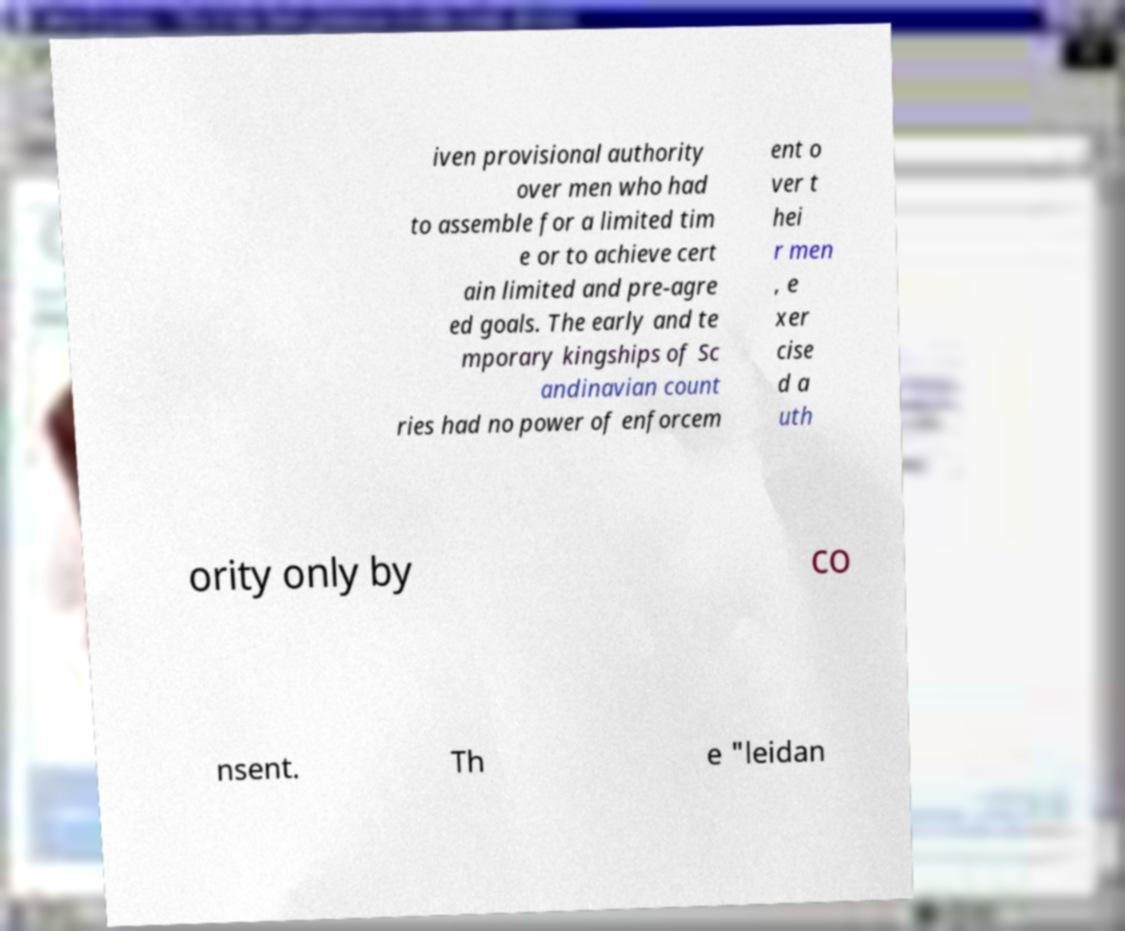Could you extract and type out the text from this image? iven provisional authority over men who had to assemble for a limited tim e or to achieve cert ain limited and pre-agre ed goals. The early and te mporary kingships of Sc andinavian count ries had no power of enforcem ent o ver t hei r men , e xer cise d a uth ority only by co nsent. Th e "leidan 